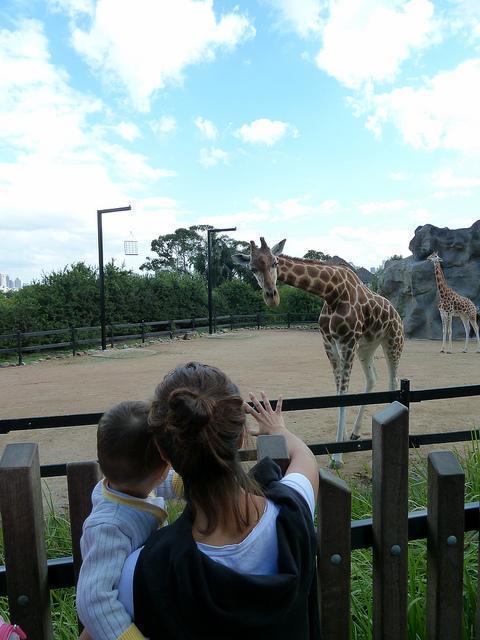What is the hanging basket for?
Answer the question by selecting the correct answer among the 4 following choices and explain your choice with a short sentence. The answer should be formatted with the following format: `Answer: choice
Rationale: rationale.`
Options: Storing food, decoration, game, lantern. Answer: storing food.
Rationale: The basket is for food. 